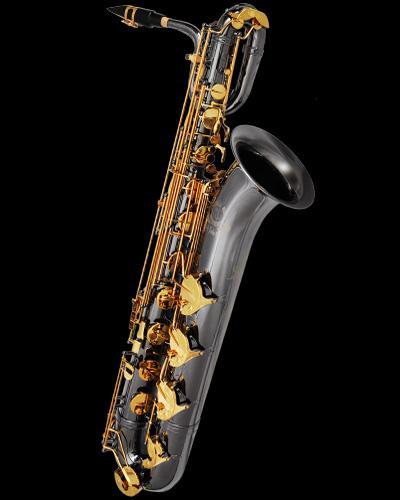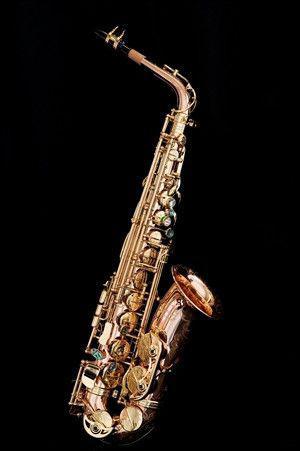The first image is the image on the left, the second image is the image on the right. Examine the images to the left and right. Is the description "No image shows a saxophone that is tilted at greater than a 45 degree angle from vertical." accurate? Answer yes or no. Yes. 